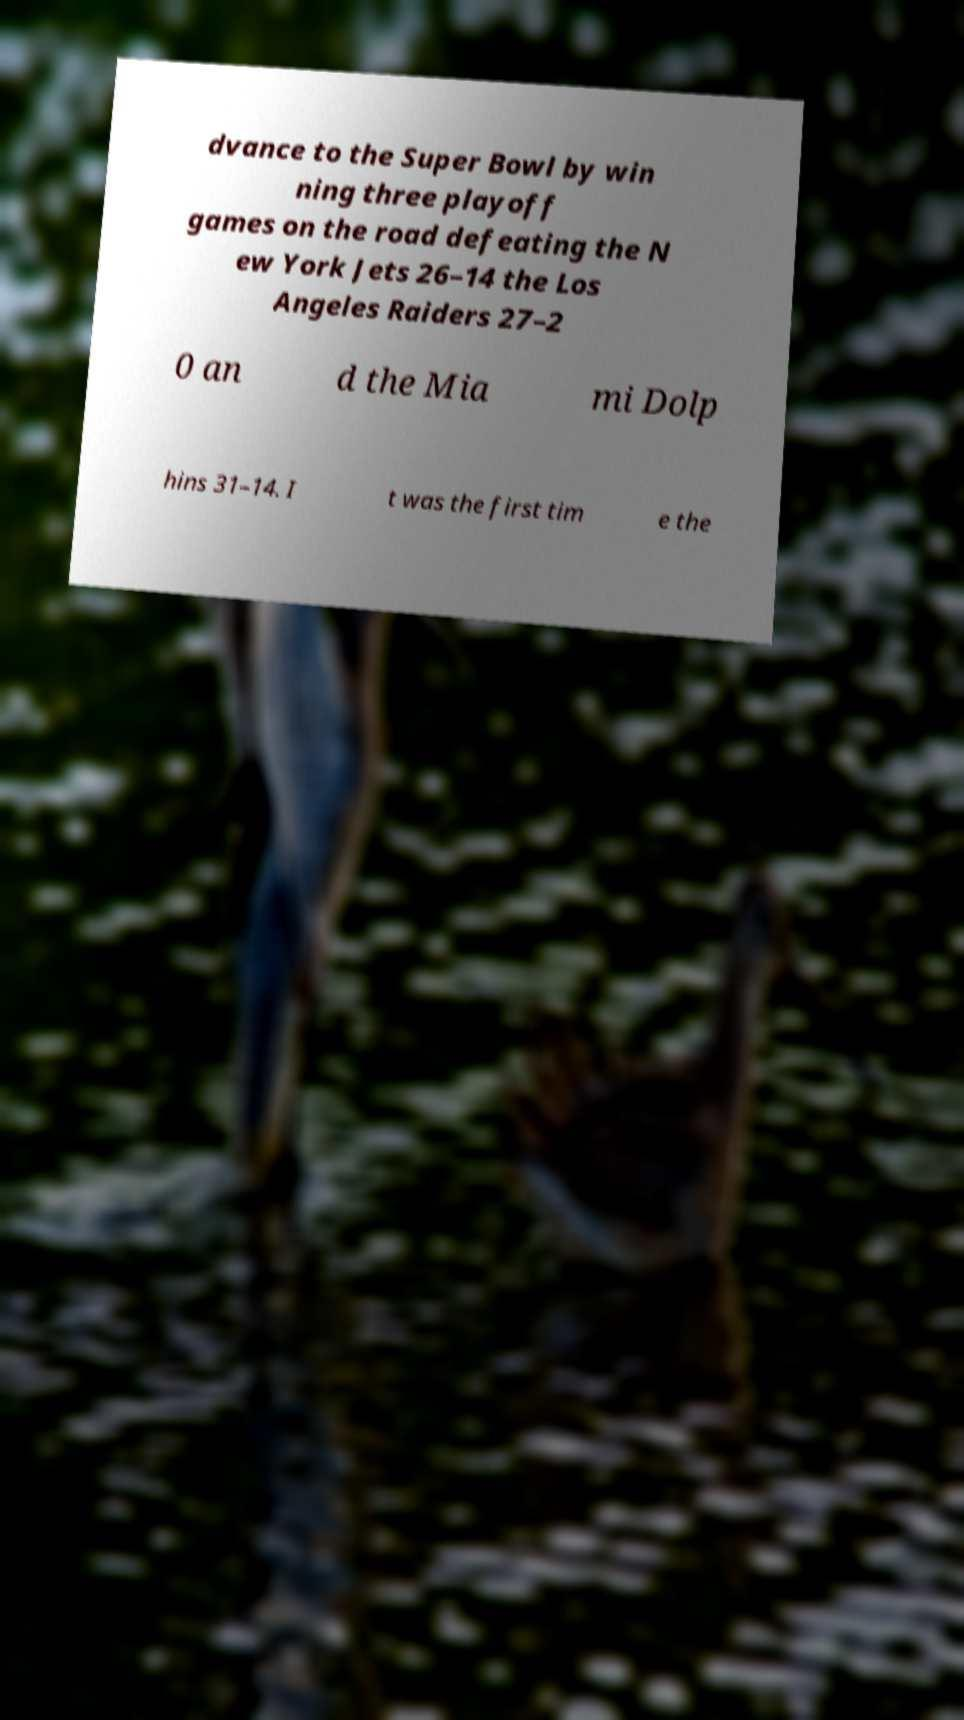What messages or text are displayed in this image? I need them in a readable, typed format. dvance to the Super Bowl by win ning three playoff games on the road defeating the N ew York Jets 26–14 the Los Angeles Raiders 27–2 0 an d the Mia mi Dolp hins 31–14. I t was the first tim e the 